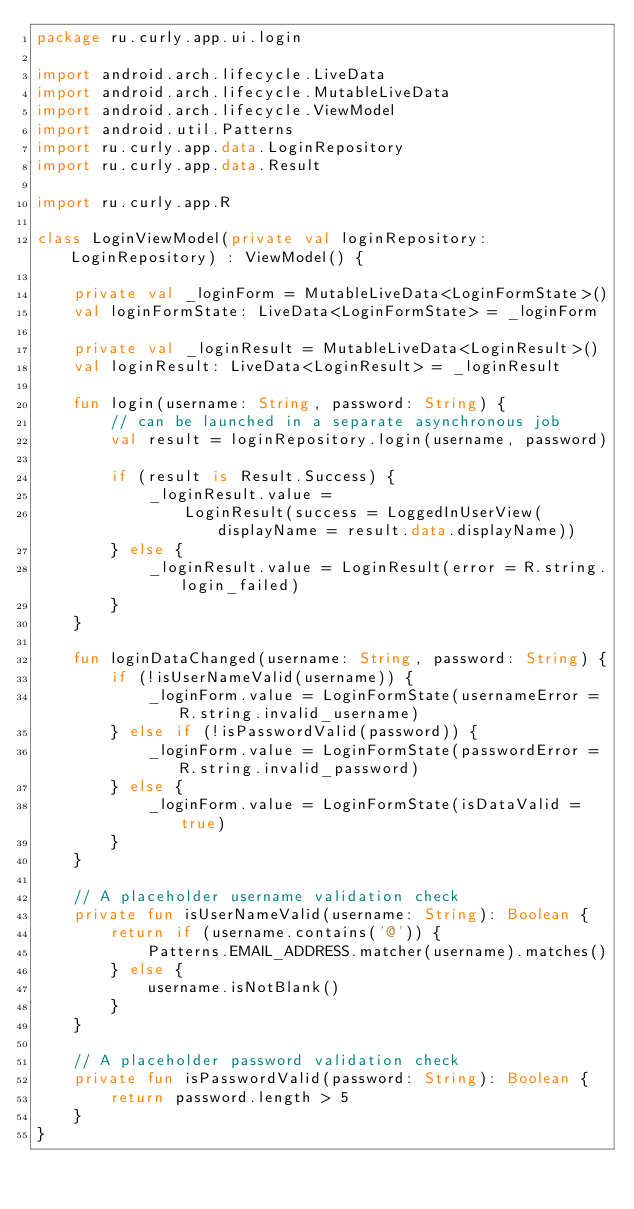<code> <loc_0><loc_0><loc_500><loc_500><_Kotlin_>package ru.curly.app.ui.login

import android.arch.lifecycle.LiveData
import android.arch.lifecycle.MutableLiveData
import android.arch.lifecycle.ViewModel
import android.util.Patterns
import ru.curly.app.data.LoginRepository
import ru.curly.app.data.Result

import ru.curly.app.R

class LoginViewModel(private val loginRepository: LoginRepository) : ViewModel() {

    private val _loginForm = MutableLiveData<LoginFormState>()
    val loginFormState: LiveData<LoginFormState> = _loginForm

    private val _loginResult = MutableLiveData<LoginResult>()
    val loginResult: LiveData<LoginResult> = _loginResult

    fun login(username: String, password: String) {
        // can be launched in a separate asynchronous job
        val result = loginRepository.login(username, password)

        if (result is Result.Success) {
            _loginResult.value =
                LoginResult(success = LoggedInUserView(displayName = result.data.displayName))
        } else {
            _loginResult.value = LoginResult(error = R.string.login_failed)
        }
    }

    fun loginDataChanged(username: String, password: String) {
        if (!isUserNameValid(username)) {
            _loginForm.value = LoginFormState(usernameError = R.string.invalid_username)
        } else if (!isPasswordValid(password)) {
            _loginForm.value = LoginFormState(passwordError = R.string.invalid_password)
        } else {
            _loginForm.value = LoginFormState(isDataValid = true)
        }
    }

    // A placeholder username validation check
    private fun isUserNameValid(username: String): Boolean {
        return if (username.contains('@')) {
            Patterns.EMAIL_ADDRESS.matcher(username).matches()
        } else {
            username.isNotBlank()
        }
    }

    // A placeholder password validation check
    private fun isPasswordValid(password: String): Boolean {
        return password.length > 5
    }
}</code> 